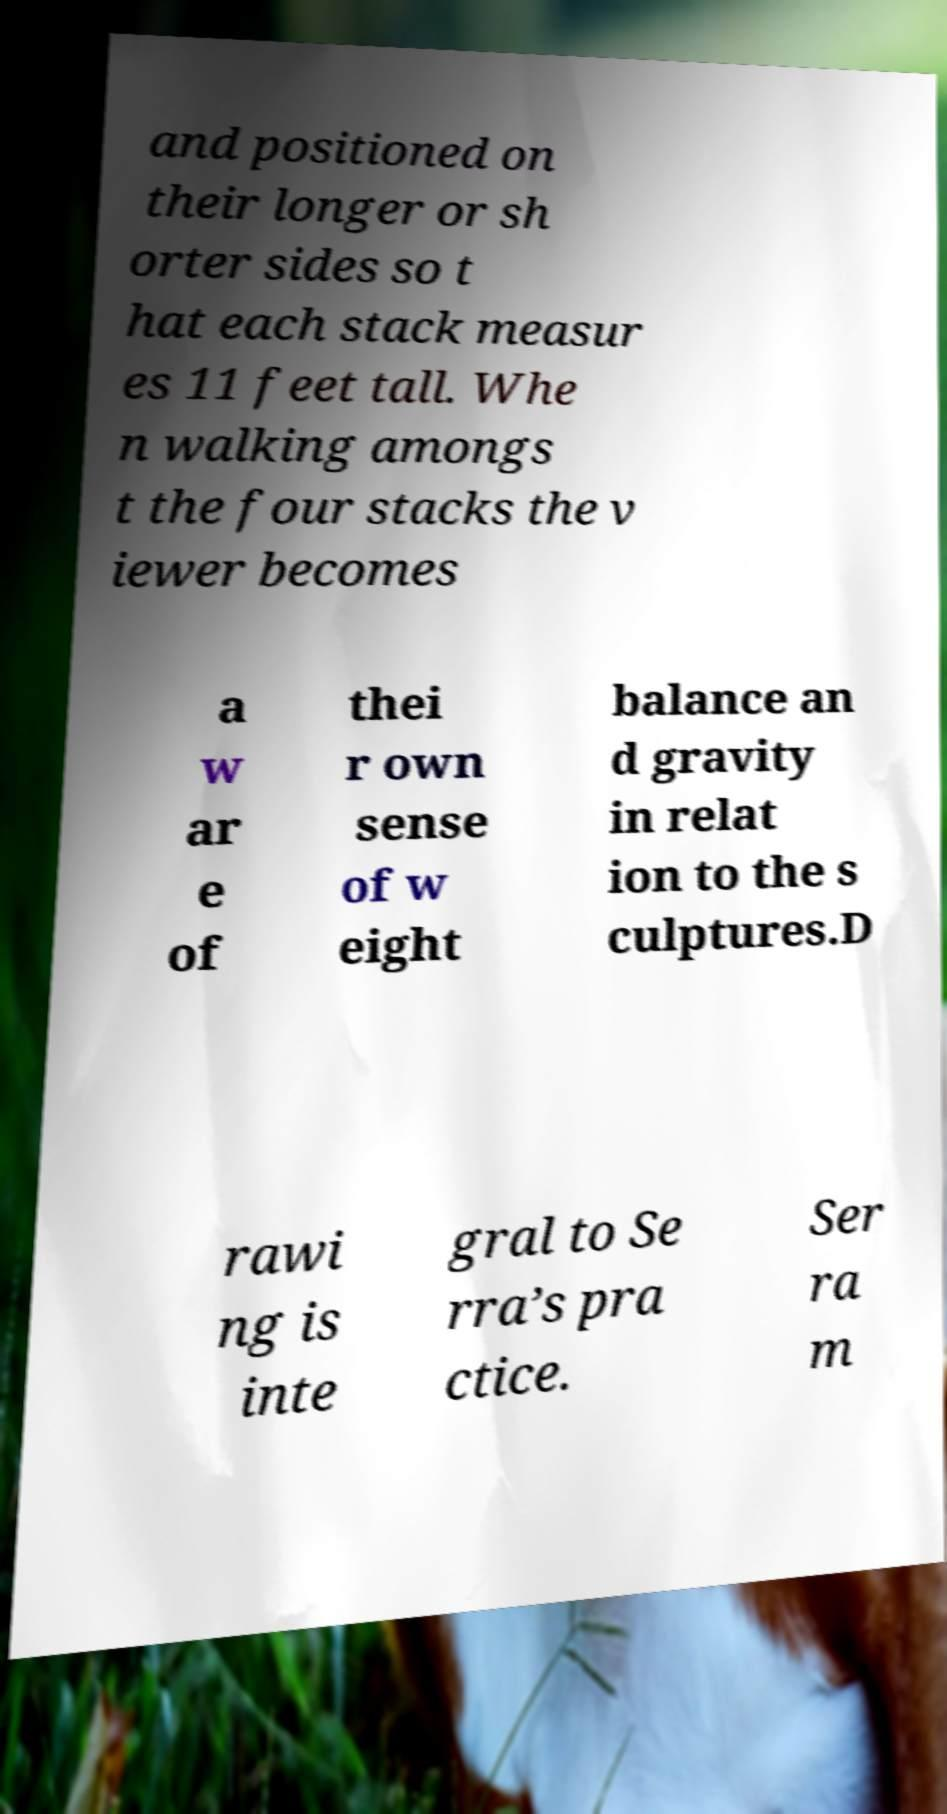Can you accurately transcribe the text from the provided image for me? and positioned on their longer or sh orter sides so t hat each stack measur es 11 feet tall. Whe n walking amongs t the four stacks the v iewer becomes a w ar e of thei r own sense of w eight balance an d gravity in relat ion to the s culptures.D rawi ng is inte gral to Se rra’s pra ctice. Ser ra m 